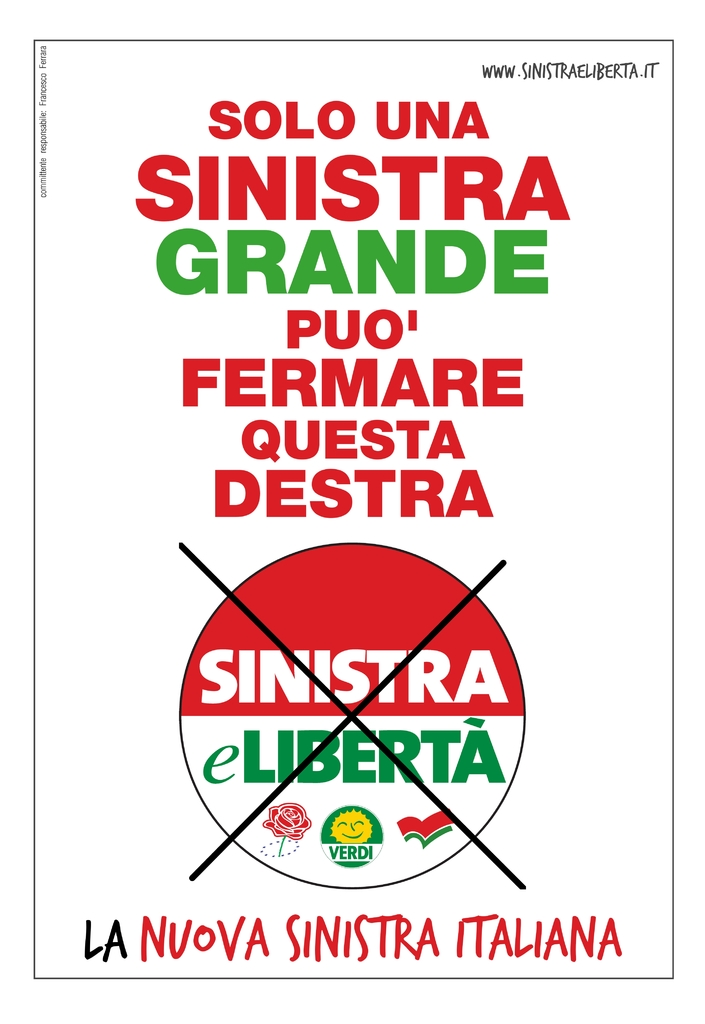Provide a one-sentence caption for the provided image. The image presents a politically charged poster featuring the phrase 'Solo Una Sinistra Grande Puo' Fermare Questa Destra' overlaid on a crossed-out logo of 'Sinistra eLiberta' with additional smaller text and emblems, suggesting a strong political message about the capabilities of a unified left in Italian politics. 